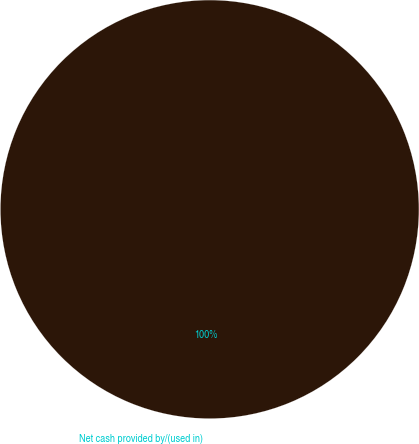Convert chart to OTSL. <chart><loc_0><loc_0><loc_500><loc_500><pie_chart><fcel>Net cash provided by/(used in)<nl><fcel>100.0%<nl></chart> 